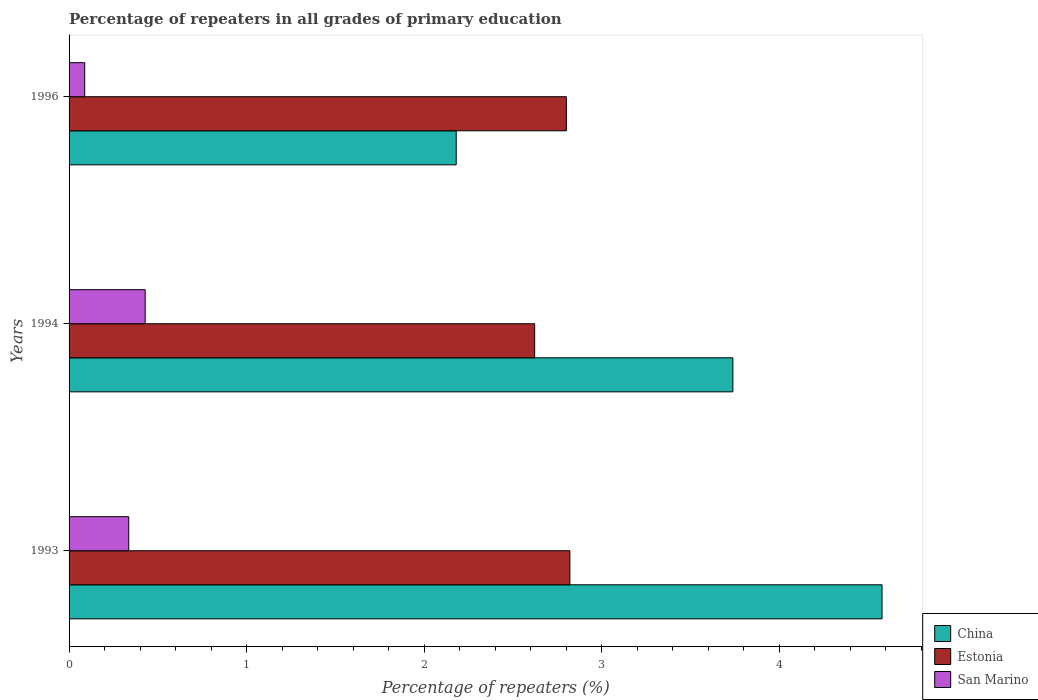How many different coloured bars are there?
Your answer should be compact. 3. Are the number of bars per tick equal to the number of legend labels?
Ensure brevity in your answer.  Yes. How many bars are there on the 3rd tick from the bottom?
Offer a terse response. 3. What is the label of the 2nd group of bars from the top?
Your answer should be very brief. 1994. In how many cases, is the number of bars for a given year not equal to the number of legend labels?
Make the answer very short. 0. What is the percentage of repeaters in China in 1993?
Your answer should be very brief. 4.58. Across all years, what is the maximum percentage of repeaters in China?
Your answer should be compact. 4.58. Across all years, what is the minimum percentage of repeaters in San Marino?
Provide a short and direct response. 0.09. What is the total percentage of repeaters in Estonia in the graph?
Provide a succinct answer. 8.25. What is the difference between the percentage of repeaters in Estonia in 1994 and that in 1996?
Keep it short and to the point. -0.18. What is the difference between the percentage of repeaters in China in 1994 and the percentage of repeaters in Estonia in 1996?
Give a very brief answer. 0.94. What is the average percentage of repeaters in China per year?
Provide a short and direct response. 3.5. In the year 1994, what is the difference between the percentage of repeaters in San Marino and percentage of repeaters in Estonia?
Offer a very short reply. -2.19. In how many years, is the percentage of repeaters in Estonia greater than 2 %?
Your answer should be very brief. 3. What is the ratio of the percentage of repeaters in Estonia in 1993 to that in 1996?
Ensure brevity in your answer.  1.01. What is the difference between the highest and the second highest percentage of repeaters in Estonia?
Your answer should be very brief. 0.02. What is the difference between the highest and the lowest percentage of repeaters in China?
Provide a succinct answer. 2.4. What does the 2nd bar from the top in 1996 represents?
Keep it short and to the point. Estonia. What does the 1st bar from the bottom in 1993 represents?
Your answer should be very brief. China. Are the values on the major ticks of X-axis written in scientific E-notation?
Your answer should be very brief. No. Does the graph contain any zero values?
Ensure brevity in your answer.  No. How many legend labels are there?
Provide a succinct answer. 3. How are the legend labels stacked?
Provide a succinct answer. Vertical. What is the title of the graph?
Offer a very short reply. Percentage of repeaters in all grades of primary education. Does "Australia" appear as one of the legend labels in the graph?
Your answer should be very brief. No. What is the label or title of the X-axis?
Provide a short and direct response. Percentage of repeaters (%). What is the Percentage of repeaters (%) of China in 1993?
Provide a succinct answer. 4.58. What is the Percentage of repeaters (%) in Estonia in 1993?
Give a very brief answer. 2.82. What is the Percentage of repeaters (%) of San Marino in 1993?
Offer a very short reply. 0.34. What is the Percentage of repeaters (%) of China in 1994?
Ensure brevity in your answer.  3.74. What is the Percentage of repeaters (%) in Estonia in 1994?
Keep it short and to the point. 2.62. What is the Percentage of repeaters (%) of San Marino in 1994?
Offer a very short reply. 0.43. What is the Percentage of repeaters (%) of China in 1996?
Your response must be concise. 2.18. What is the Percentage of repeaters (%) of Estonia in 1996?
Provide a short and direct response. 2.8. What is the Percentage of repeaters (%) of San Marino in 1996?
Offer a very short reply. 0.09. Across all years, what is the maximum Percentage of repeaters (%) of China?
Offer a very short reply. 4.58. Across all years, what is the maximum Percentage of repeaters (%) in Estonia?
Keep it short and to the point. 2.82. Across all years, what is the maximum Percentage of repeaters (%) of San Marino?
Provide a succinct answer. 0.43. Across all years, what is the minimum Percentage of repeaters (%) in China?
Make the answer very short. 2.18. Across all years, what is the minimum Percentage of repeaters (%) of Estonia?
Offer a terse response. 2.62. Across all years, what is the minimum Percentage of repeaters (%) of San Marino?
Give a very brief answer. 0.09. What is the total Percentage of repeaters (%) in China in the graph?
Offer a very short reply. 10.5. What is the total Percentage of repeaters (%) in Estonia in the graph?
Provide a short and direct response. 8.25. What is the total Percentage of repeaters (%) of San Marino in the graph?
Your response must be concise. 0.85. What is the difference between the Percentage of repeaters (%) in China in 1993 and that in 1994?
Provide a succinct answer. 0.84. What is the difference between the Percentage of repeaters (%) of Estonia in 1993 and that in 1994?
Offer a very short reply. 0.2. What is the difference between the Percentage of repeaters (%) in San Marino in 1993 and that in 1994?
Provide a succinct answer. -0.09. What is the difference between the Percentage of repeaters (%) of China in 1993 and that in 1996?
Provide a succinct answer. 2.4. What is the difference between the Percentage of repeaters (%) in Estonia in 1993 and that in 1996?
Your answer should be very brief. 0.02. What is the difference between the Percentage of repeaters (%) in San Marino in 1993 and that in 1996?
Make the answer very short. 0.25. What is the difference between the Percentage of repeaters (%) in China in 1994 and that in 1996?
Provide a short and direct response. 1.56. What is the difference between the Percentage of repeaters (%) of Estonia in 1994 and that in 1996?
Provide a succinct answer. -0.18. What is the difference between the Percentage of repeaters (%) of San Marino in 1994 and that in 1996?
Your answer should be compact. 0.34. What is the difference between the Percentage of repeaters (%) in China in 1993 and the Percentage of repeaters (%) in Estonia in 1994?
Offer a terse response. 1.96. What is the difference between the Percentage of repeaters (%) of China in 1993 and the Percentage of repeaters (%) of San Marino in 1994?
Offer a terse response. 4.15. What is the difference between the Percentage of repeaters (%) in Estonia in 1993 and the Percentage of repeaters (%) in San Marino in 1994?
Your answer should be compact. 2.39. What is the difference between the Percentage of repeaters (%) in China in 1993 and the Percentage of repeaters (%) in Estonia in 1996?
Make the answer very short. 1.78. What is the difference between the Percentage of repeaters (%) of China in 1993 and the Percentage of repeaters (%) of San Marino in 1996?
Ensure brevity in your answer.  4.49. What is the difference between the Percentage of repeaters (%) in Estonia in 1993 and the Percentage of repeaters (%) in San Marino in 1996?
Your answer should be compact. 2.73. What is the difference between the Percentage of repeaters (%) of China in 1994 and the Percentage of repeaters (%) of Estonia in 1996?
Make the answer very short. 0.94. What is the difference between the Percentage of repeaters (%) in China in 1994 and the Percentage of repeaters (%) in San Marino in 1996?
Offer a terse response. 3.65. What is the difference between the Percentage of repeaters (%) of Estonia in 1994 and the Percentage of repeaters (%) of San Marino in 1996?
Offer a very short reply. 2.53. What is the average Percentage of repeaters (%) in China per year?
Offer a very short reply. 3.5. What is the average Percentage of repeaters (%) in Estonia per year?
Keep it short and to the point. 2.75. What is the average Percentage of repeaters (%) in San Marino per year?
Offer a very short reply. 0.28. In the year 1993, what is the difference between the Percentage of repeaters (%) in China and Percentage of repeaters (%) in Estonia?
Provide a short and direct response. 1.76. In the year 1993, what is the difference between the Percentage of repeaters (%) in China and Percentage of repeaters (%) in San Marino?
Provide a short and direct response. 4.24. In the year 1993, what is the difference between the Percentage of repeaters (%) of Estonia and Percentage of repeaters (%) of San Marino?
Keep it short and to the point. 2.49. In the year 1994, what is the difference between the Percentage of repeaters (%) in China and Percentage of repeaters (%) in Estonia?
Ensure brevity in your answer.  1.12. In the year 1994, what is the difference between the Percentage of repeaters (%) in China and Percentage of repeaters (%) in San Marino?
Your answer should be very brief. 3.31. In the year 1994, what is the difference between the Percentage of repeaters (%) in Estonia and Percentage of repeaters (%) in San Marino?
Your answer should be very brief. 2.19. In the year 1996, what is the difference between the Percentage of repeaters (%) of China and Percentage of repeaters (%) of Estonia?
Provide a short and direct response. -0.62. In the year 1996, what is the difference between the Percentage of repeaters (%) in China and Percentage of repeaters (%) in San Marino?
Provide a short and direct response. 2.09. In the year 1996, what is the difference between the Percentage of repeaters (%) of Estonia and Percentage of repeaters (%) of San Marino?
Give a very brief answer. 2.71. What is the ratio of the Percentage of repeaters (%) in China in 1993 to that in 1994?
Provide a short and direct response. 1.22. What is the ratio of the Percentage of repeaters (%) in Estonia in 1993 to that in 1994?
Ensure brevity in your answer.  1.08. What is the ratio of the Percentage of repeaters (%) of San Marino in 1993 to that in 1994?
Offer a very short reply. 0.78. What is the ratio of the Percentage of repeaters (%) in China in 1993 to that in 1996?
Provide a succinct answer. 2.1. What is the ratio of the Percentage of repeaters (%) in Estonia in 1993 to that in 1996?
Your response must be concise. 1.01. What is the ratio of the Percentage of repeaters (%) in San Marino in 1993 to that in 1996?
Offer a terse response. 3.81. What is the ratio of the Percentage of repeaters (%) in China in 1994 to that in 1996?
Provide a short and direct response. 1.71. What is the ratio of the Percentage of repeaters (%) of Estonia in 1994 to that in 1996?
Offer a terse response. 0.94. What is the ratio of the Percentage of repeaters (%) in San Marino in 1994 to that in 1996?
Give a very brief answer. 4.86. What is the difference between the highest and the second highest Percentage of repeaters (%) in China?
Your answer should be very brief. 0.84. What is the difference between the highest and the second highest Percentage of repeaters (%) in Estonia?
Offer a very short reply. 0.02. What is the difference between the highest and the second highest Percentage of repeaters (%) of San Marino?
Your response must be concise. 0.09. What is the difference between the highest and the lowest Percentage of repeaters (%) in China?
Ensure brevity in your answer.  2.4. What is the difference between the highest and the lowest Percentage of repeaters (%) of Estonia?
Provide a succinct answer. 0.2. What is the difference between the highest and the lowest Percentage of repeaters (%) of San Marino?
Your answer should be very brief. 0.34. 